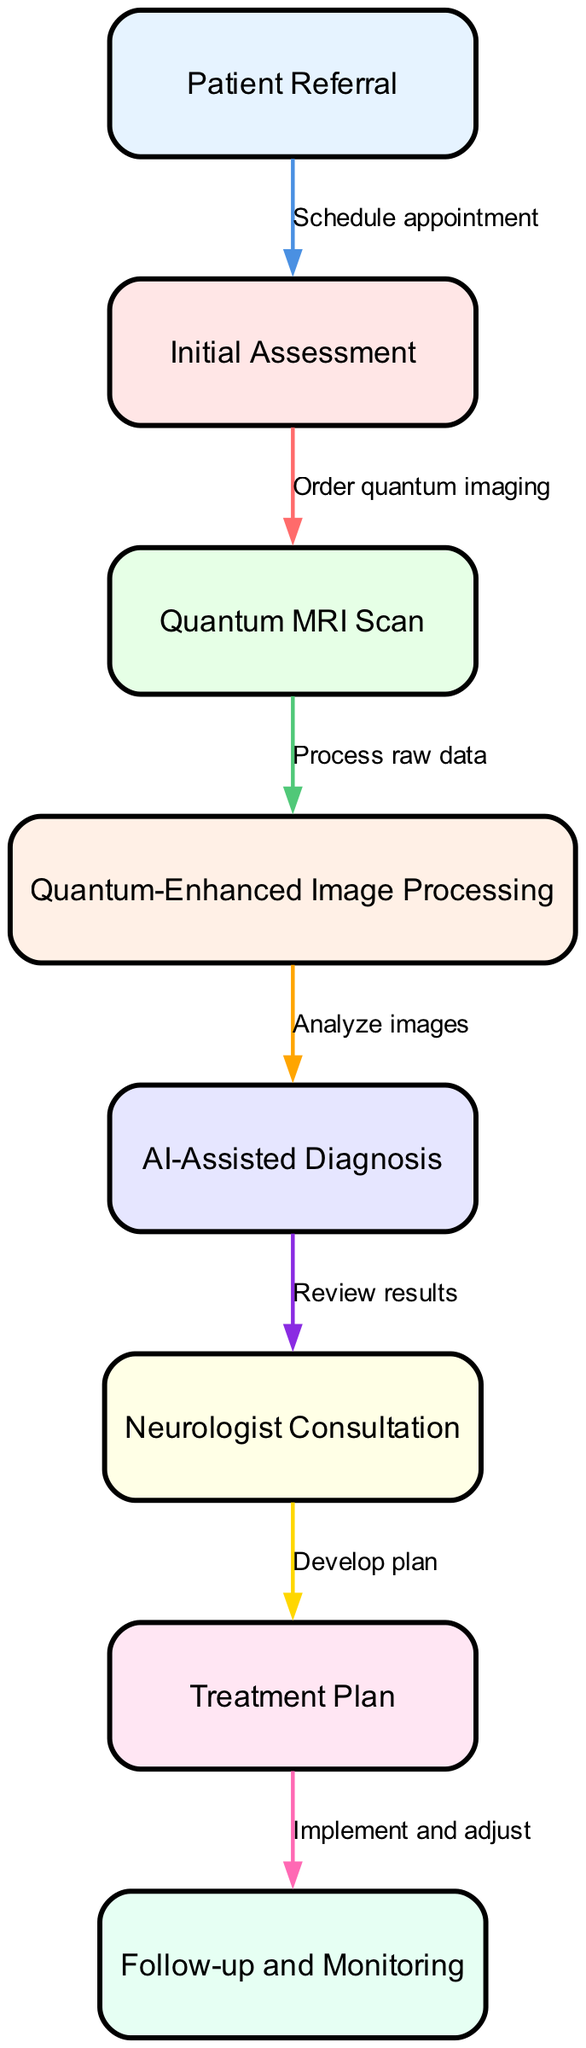What is the first step in the clinical pathway? The first step in the clinical pathway is represented by the first node, which is "Patient Referral".
Answer: Patient Referral How many nodes are there in the diagram? By counting the nodes listed in the data, there are a total of 8 nodes depicted in the diagram.
Answer: 8 What connects "Initial Assessment" to "Quantum MRI Scan"? The two nodes are connected by the labeled edge, which indicates the action "Order quantum imaging" that takes place between them.
Answer: Order quantum imaging What happens after the "Quantum MRI Scan"? After the "Quantum MRI Scan," the next step is "Quantum-Enhanced Image Processing," as shown by the directed edge in the diagram.
Answer: Quantum-Enhanced Image Processing Which node is directly connected to "AI-Assisted Diagnosis"? The node that is directly connected to "AI-Assisted Diagnosis" is "Neurologist Consultation," as indicated by the directed edge leading from one to the other.
Answer: Neurologist Consultation What label is used for the edge between "Treatment Plan" and "Follow-up and Monitoring"? The label for the edge connecting "Treatment Plan" to "Follow-up and Monitoring" is "Implement and adjust," describing the action taken at this stage.
Answer: Implement and adjust What is the relationship between "Quantum-Enhanced Image Processing" and "AI-Assisted Diagnosis"? The relationship is that "Quantum-Enhanced Image Processing" feeds into "AI-Assisted Diagnosis" via the connecting edge labeled "Analyze images," indicating a sequential flow of information.
Answer: Analyze images What is the final step in the clinical pathway? The final step is "Follow-up and Monitoring," which is the last node in the sequence of the pathway.
Answer: Follow-up and Monitoring How does the process begin? The process begins with the node "Patient Referral," indicating that it is the starting point of the clinical pathway.
Answer: Patient Referral 